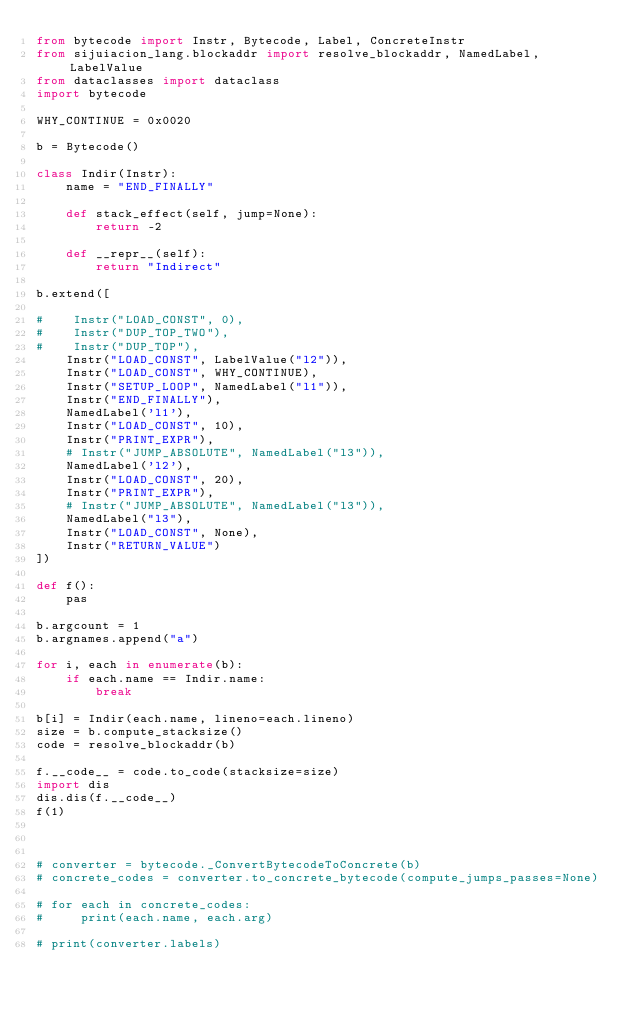Convert code to text. <code><loc_0><loc_0><loc_500><loc_500><_Python_>from bytecode import Instr, Bytecode, Label, ConcreteInstr
from sijuiacion_lang.blockaddr import resolve_blockaddr, NamedLabel, LabelValue
from dataclasses import dataclass
import bytecode

WHY_CONTINUE = 0x0020

b = Bytecode()

class Indir(Instr):
    name = "END_FINALLY"

    def stack_effect(self, jump=None):
        return -2

    def __repr__(self):
        return "Indirect"
    
b.extend([

#    Instr("LOAD_CONST", 0),
#    Instr("DUP_TOP_TWO"),
#    Instr("DUP_TOP"),
    Instr("LOAD_CONST", LabelValue("l2")),
    Instr("LOAD_CONST", WHY_CONTINUE),
    Instr("SETUP_LOOP", NamedLabel("l1")),
    Instr("END_FINALLY"),
    NamedLabel('l1'),
    Instr("LOAD_CONST", 10),
    Instr("PRINT_EXPR"),
    # Instr("JUMP_ABSOLUTE", NamedLabel("l3")),
    NamedLabel('l2'),
    Instr("LOAD_CONST", 20),
    Instr("PRINT_EXPR"),
    # Instr("JUMP_ABSOLUTE", NamedLabel("l3")),
    NamedLabel("l3"),
    Instr("LOAD_CONST", None),
    Instr("RETURN_VALUE")
])

def f():
    pas

b.argcount = 1
b.argnames.append("a")

for i, each in enumerate(b):
    if each.name == Indir.name:
        break

b[i] = Indir(each.name, lineno=each.lineno)
size = b.compute_stacksize()
code = resolve_blockaddr(b)

f.__code__ = code.to_code(stacksize=size)
import dis
dis.dis(f.__code__)
f(1)



# converter = bytecode._ConvertBytecodeToConcrete(b)
# concrete_codes = converter.to_concrete_bytecode(compute_jumps_passes=None)

# for each in concrete_codes:
#     print(each.name, each.arg)

# print(converter.labels)
</code> 